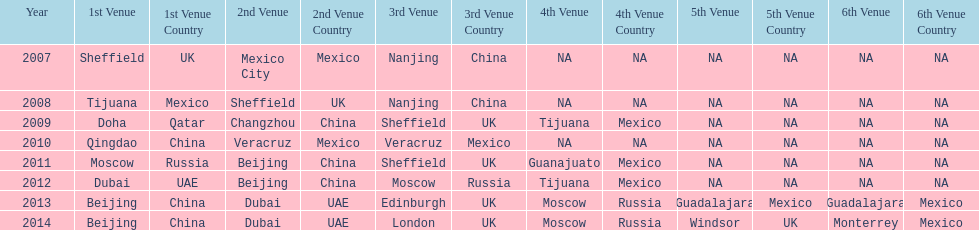Name a year whose second venue was the same as 2011. 2012. 